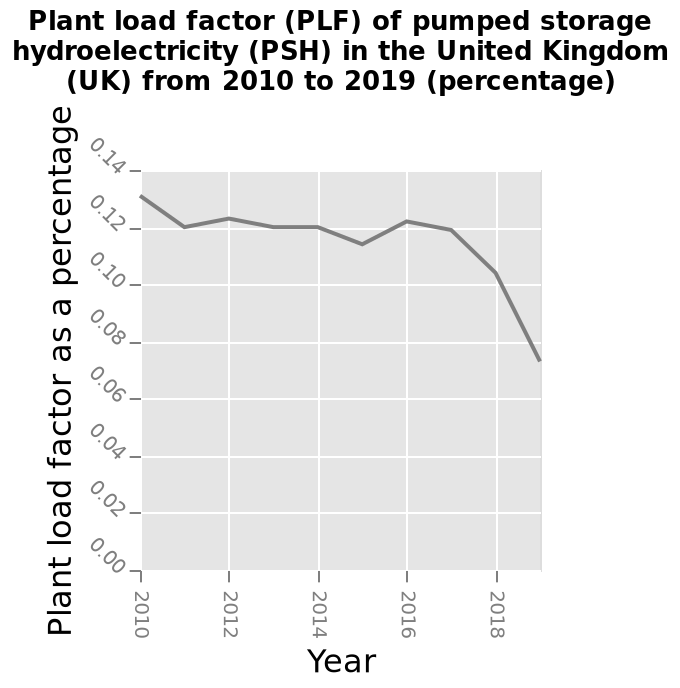<image>
please enumerates aspects of the construction of the chart Plant load factor (PLF) of pumped storage hydroelectricity (PSH) in the United Kingdom (UK) from 2010 to 2019 (percentage) is a line graph. On the y-axis, Plant load factor as a percentage is shown with a linear scale with a minimum of 0.00 and a maximum of 0.14. Along the x-axis, Year is shown. Can you provide more specific data or numbers on the decrease in the plant load factor of pumped storage? Unfortunately, specific data or numbers on the decrease in the plant load factor of pumped storage are not provided in the given information. How has the plant load factor of pumped storage changed in recent years? The plant load factor of pumped storage has decreased dramatically over recent years (2016 - 2020). 